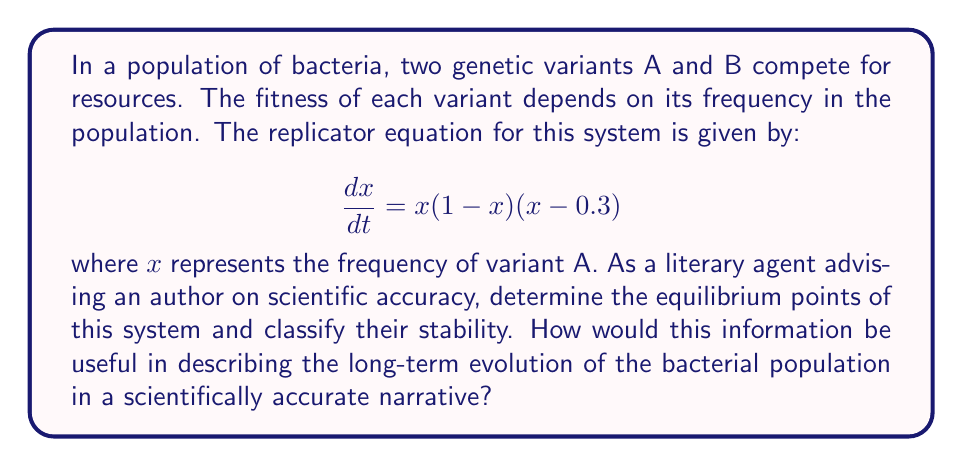Can you answer this question? 1. To find the equilibrium points, set $\frac{dx}{dt} = 0$:
   $$x(1-x)(x-0.3) = 0$$

2. Solve for x:
   $x = 0$, $x = 1$, or $x = 0.3$

3. To classify stability, examine the derivative of $\frac{dx}{dt}$ at each equilibrium point:
   $$\frac{d}{dx}\left(\frac{dx}{dt}\right) = (1-x)(x-0.3) + x(x-0.3) + x(1-x)$$
   $$= 1 - 2x + 0.3 + x^2 - 0.3x + x - x^2 = 1.3 - 2.3x + x^2$$

4. Evaluate at each equilibrium point:
   At $x = 0$: $1.3 > 0$ (unstable)
   At $x = 1$: $0 < 0$ (stable)
   At $x = 0.3$: $0.091 > 0$ (unstable)

5. Interpretation for narrative:
   - $x = 0$ (only B present) is unstable: small introduction of A will grow
   - $x = 1$ (only A present) is stable: population will tend towards this state
   - $x = 0.3$ is unstable: population will move away from this mixed state

This information can be used to describe a scientifically accurate narrative where variant A has a competitive advantage and will eventually dominate the population, despite initial coexistence with variant B.
Answer: Equilibrium points: $x = 0$ (unstable), $x = 1$ (stable), $x = 0.3$ (unstable). Variant A will dominate over time. 